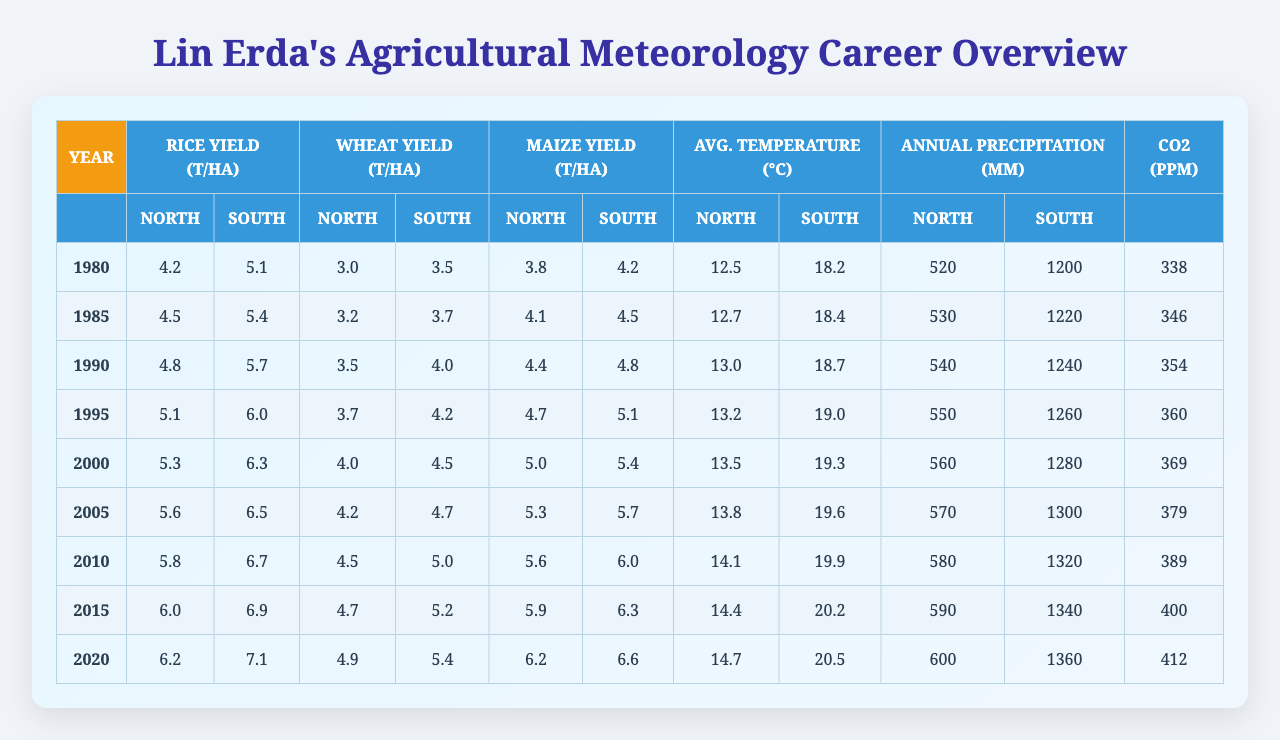What is the rice yield in South China in the year 2000? In the table, under the column for "Rice Yield South China," the value for the year 2000 is 6.3.
Answer: 6.3 What was the average wheat yield in North China from 1980 to 2020? To find the average, we first add up all the wheat yields in North China over the years: (3.0 + 3.2 + 3.5 + 3.7 + 4.0 + 4.2 + 4.5 + 4.7 + 4.9) = 36.7. Then, we divide this sum by the number of data points, which is 9, resulting in an average of 36.7/9 ≈ 4.07.
Answer: 4.07 Has the maize yield in South China ever exceeded 6.0 t/ha by 2020? Looking at the "Maize Yield South China" column, the value exceeds 6.0 t/ha for every year from 2010 onward: 6.0, 6.3, and 6.6 in 2015, 2020 respectively. Therefore, the answer is yes.
Answer: Yes What is the trend in average temperature in North China from 1980 to 2020? By examining the "Average Temperature North China" column, we observe that the temperatures have steadily increased from 12.5°C in 1980 to 14.7°C in 2020, indicating a rising trend over the years.
Answer: Rising trend In which year did South China's wheat yield surpass North China's wheat yield by the highest margin? We compare the values from both "Wheat Yield North China" and "Wheat Yield South China." The highest margin occurs in 2020, where South China’s yield is 5.4 compared to North China’s 4.9, resulting in a margin of 0.5. Checking other years confirms this is the largest margin.
Answer: 2020 What is the difference in rice yield between North and South China in 1995? In 1995, North China's rice yield is 5.1 t/ha, and South China's is 6.0 t/ha. The difference between the two yields is 6.0 - 5.1 = 0.9 t/ha.
Answer: 0.9 t/ha What is the year-on-year change in maize yield in North China from 2010 to 2015? The maize yield in North China was 5.6 t/ha in 2010 and increased to 5.9 t/ha in 2015. Therefore, the year-on-year change is 5.9 - 5.6 = 0.3 t/ha.
Answer: 0.3 t/ha Did CO2 concentration growth consistently correlate with increasing crop yields from 1980 to 2020? By observing both the "CO2 Concentration" values and the various crop yields, we see an overall increase in both. However, examining yield data from specific years shows inconsistencies, suggesting that while there is a general correlation, it is not consistent across all years.
Answer: No, not consistent What was the average annual precipitation in South China during Lin Erda's career? Adding the annual precipitation from South China: (1200 + 1220 + 1240 + 1260 + 1280 + 1300 + 1320 + 1340 + 1360) = 11920. Dividing this by 9 gives an average of 11920/9 ≈ 1324.44.
Answer: 1324.44 mm Which crop yield grew the most from 1980 to 2020 in North China? Analyzing the data for North China, rice yield increased from 4.2 to 6.2 (2.0 increase), wheat yield from 3.0 to 4.9 (1.9 increase), and maize yield from 3.8 to 6.2 (2.4 increase). The biggest increase is in maize, which grew by 2.4 t/ha.
Answer: Maize yield 